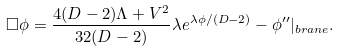Convert formula to latex. <formula><loc_0><loc_0><loc_500><loc_500>\Box \phi = \frac { 4 ( D - 2 ) \Lambda + V ^ { 2 } } { 3 2 ( D - 2 ) } \lambda e ^ { \lambda \phi / ( D - 2 ) } - \phi ^ { \prime \prime } | _ { b r a n e } .</formula> 